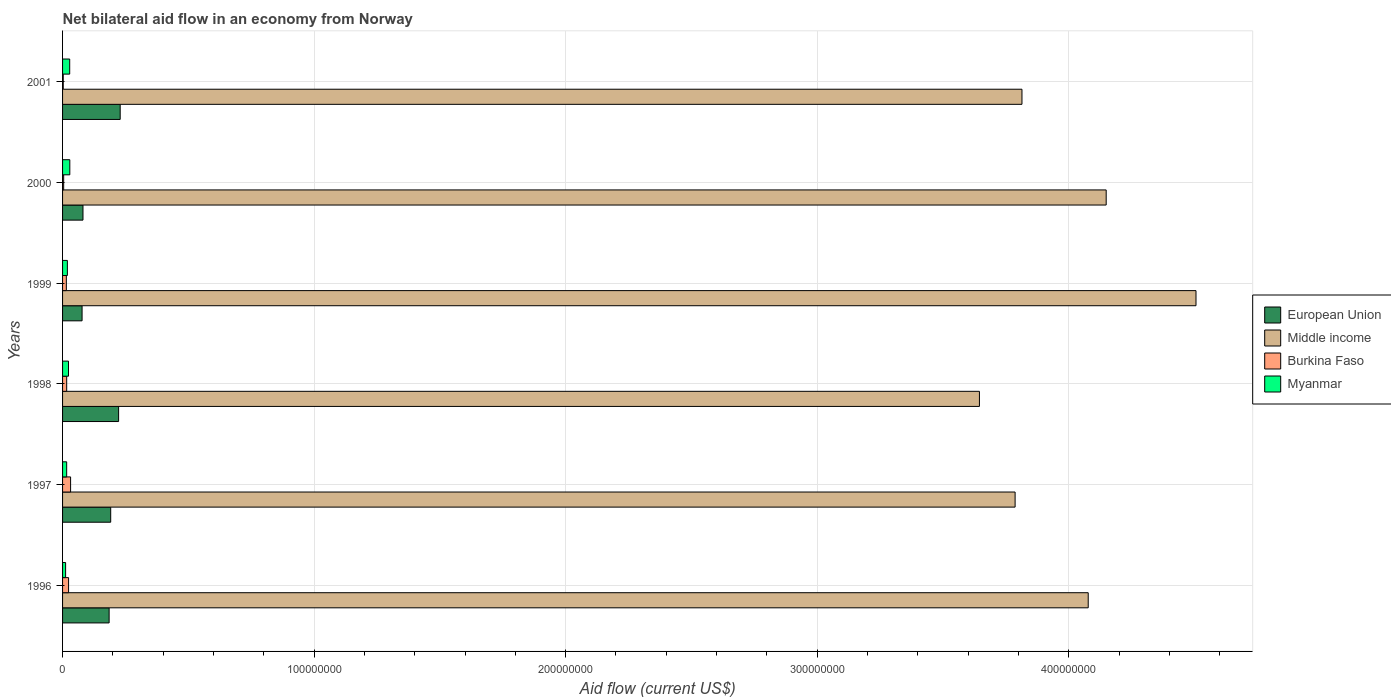How many groups of bars are there?
Offer a very short reply. 6. Are the number of bars per tick equal to the number of legend labels?
Give a very brief answer. Yes. Are the number of bars on each tick of the Y-axis equal?
Your response must be concise. Yes. How many bars are there on the 2nd tick from the top?
Give a very brief answer. 4. What is the label of the 2nd group of bars from the top?
Offer a terse response. 2000. In how many cases, is the number of bars for a given year not equal to the number of legend labels?
Your answer should be compact. 0. What is the net bilateral aid flow in Myanmar in 2001?
Offer a very short reply. 2.84e+06. Across all years, what is the maximum net bilateral aid flow in Middle income?
Keep it short and to the point. 4.51e+08. Across all years, what is the minimum net bilateral aid flow in Middle income?
Your answer should be very brief. 3.65e+08. In which year was the net bilateral aid flow in Burkina Faso maximum?
Offer a terse response. 1997. In which year was the net bilateral aid flow in European Union minimum?
Offer a very short reply. 1999. What is the total net bilateral aid flow in Middle income in the graph?
Provide a succinct answer. 2.40e+09. What is the difference between the net bilateral aid flow in Myanmar in 1999 and that in 2001?
Your response must be concise. -9.30e+05. What is the average net bilateral aid flow in Burkina Faso per year?
Keep it short and to the point. 1.57e+06. In the year 1996, what is the difference between the net bilateral aid flow in Myanmar and net bilateral aid flow in European Union?
Ensure brevity in your answer.  -1.73e+07. In how many years, is the net bilateral aid flow in Burkina Faso greater than 240000000 US$?
Keep it short and to the point. 0. What is the ratio of the net bilateral aid flow in Myanmar in 1997 to that in 1998?
Keep it short and to the point. 0.69. Is the net bilateral aid flow in Middle income in 1997 less than that in 2001?
Your answer should be very brief. Yes. Is the difference between the net bilateral aid flow in Myanmar in 1998 and 2001 greater than the difference between the net bilateral aid flow in European Union in 1998 and 2001?
Offer a very short reply. Yes. What is the difference between the highest and the second highest net bilateral aid flow in Myanmar?
Provide a short and direct response. 4.00e+04. What is the difference between the highest and the lowest net bilateral aid flow in European Union?
Your answer should be very brief. 1.52e+07. In how many years, is the net bilateral aid flow in European Union greater than the average net bilateral aid flow in European Union taken over all years?
Offer a very short reply. 4. Is the sum of the net bilateral aid flow in Myanmar in 1996 and 1997 greater than the maximum net bilateral aid flow in Burkina Faso across all years?
Your answer should be very brief. No. What does the 2nd bar from the top in 1996 represents?
Your answer should be very brief. Burkina Faso. What does the 3rd bar from the bottom in 1999 represents?
Offer a terse response. Burkina Faso. Is it the case that in every year, the sum of the net bilateral aid flow in European Union and net bilateral aid flow in Myanmar is greater than the net bilateral aid flow in Burkina Faso?
Your answer should be compact. Yes. How many years are there in the graph?
Your answer should be compact. 6. Where does the legend appear in the graph?
Give a very brief answer. Center right. How many legend labels are there?
Provide a succinct answer. 4. What is the title of the graph?
Your answer should be compact. Net bilateral aid flow in an economy from Norway. What is the label or title of the Y-axis?
Offer a very short reply. Years. What is the Aid flow (current US$) of European Union in 1996?
Your response must be concise. 1.85e+07. What is the Aid flow (current US$) of Middle income in 1996?
Offer a very short reply. 4.08e+08. What is the Aid flow (current US$) of Burkina Faso in 1996?
Offer a terse response. 2.39e+06. What is the Aid flow (current US$) of Myanmar in 1996?
Your response must be concise. 1.21e+06. What is the Aid flow (current US$) in European Union in 1997?
Keep it short and to the point. 1.91e+07. What is the Aid flow (current US$) in Middle income in 1997?
Provide a short and direct response. 3.79e+08. What is the Aid flow (current US$) of Burkina Faso in 1997?
Keep it short and to the point. 3.19e+06. What is the Aid flow (current US$) in Myanmar in 1997?
Provide a short and direct response. 1.63e+06. What is the Aid flow (current US$) of European Union in 1998?
Provide a short and direct response. 2.23e+07. What is the Aid flow (current US$) in Middle income in 1998?
Ensure brevity in your answer.  3.65e+08. What is the Aid flow (current US$) in Burkina Faso in 1998?
Keep it short and to the point. 1.64e+06. What is the Aid flow (current US$) in Myanmar in 1998?
Ensure brevity in your answer.  2.36e+06. What is the Aid flow (current US$) of European Union in 1999?
Ensure brevity in your answer.  7.76e+06. What is the Aid flow (current US$) of Middle income in 1999?
Offer a terse response. 4.51e+08. What is the Aid flow (current US$) of Burkina Faso in 1999?
Your response must be concise. 1.50e+06. What is the Aid flow (current US$) of Myanmar in 1999?
Your answer should be very brief. 1.91e+06. What is the Aid flow (current US$) in European Union in 2000?
Make the answer very short. 8.12e+06. What is the Aid flow (current US$) in Middle income in 2000?
Keep it short and to the point. 4.15e+08. What is the Aid flow (current US$) in Myanmar in 2000?
Make the answer very short. 2.88e+06. What is the Aid flow (current US$) in European Union in 2001?
Your answer should be compact. 2.29e+07. What is the Aid flow (current US$) of Middle income in 2001?
Keep it short and to the point. 3.81e+08. What is the Aid flow (current US$) of Myanmar in 2001?
Your answer should be very brief. 2.84e+06. Across all years, what is the maximum Aid flow (current US$) in European Union?
Provide a short and direct response. 2.29e+07. Across all years, what is the maximum Aid flow (current US$) in Middle income?
Offer a terse response. 4.51e+08. Across all years, what is the maximum Aid flow (current US$) in Burkina Faso?
Offer a very short reply. 3.19e+06. Across all years, what is the maximum Aid flow (current US$) in Myanmar?
Ensure brevity in your answer.  2.88e+06. Across all years, what is the minimum Aid flow (current US$) in European Union?
Offer a terse response. 7.76e+06. Across all years, what is the minimum Aid flow (current US$) of Middle income?
Your answer should be compact. 3.65e+08. Across all years, what is the minimum Aid flow (current US$) in Myanmar?
Provide a short and direct response. 1.21e+06. What is the total Aid flow (current US$) in European Union in the graph?
Your answer should be very brief. 9.87e+07. What is the total Aid flow (current US$) of Middle income in the graph?
Give a very brief answer. 2.40e+09. What is the total Aid flow (current US$) in Burkina Faso in the graph?
Your answer should be very brief. 9.43e+06. What is the total Aid flow (current US$) in Myanmar in the graph?
Ensure brevity in your answer.  1.28e+07. What is the difference between the Aid flow (current US$) of European Union in 1996 and that in 1997?
Your answer should be very brief. -6.30e+05. What is the difference between the Aid flow (current US$) in Middle income in 1996 and that in 1997?
Give a very brief answer. 2.91e+07. What is the difference between the Aid flow (current US$) of Burkina Faso in 1996 and that in 1997?
Make the answer very short. -8.00e+05. What is the difference between the Aid flow (current US$) in Myanmar in 1996 and that in 1997?
Ensure brevity in your answer.  -4.20e+05. What is the difference between the Aid flow (current US$) in European Union in 1996 and that in 1998?
Provide a short and direct response. -3.77e+06. What is the difference between the Aid flow (current US$) in Middle income in 1996 and that in 1998?
Offer a terse response. 4.32e+07. What is the difference between the Aid flow (current US$) of Burkina Faso in 1996 and that in 1998?
Keep it short and to the point. 7.50e+05. What is the difference between the Aid flow (current US$) of Myanmar in 1996 and that in 1998?
Make the answer very short. -1.15e+06. What is the difference between the Aid flow (current US$) of European Union in 1996 and that in 1999?
Ensure brevity in your answer.  1.08e+07. What is the difference between the Aid flow (current US$) in Middle income in 1996 and that in 1999?
Offer a very short reply. -4.28e+07. What is the difference between the Aid flow (current US$) of Burkina Faso in 1996 and that in 1999?
Keep it short and to the point. 8.90e+05. What is the difference between the Aid flow (current US$) of Myanmar in 1996 and that in 1999?
Offer a terse response. -7.00e+05. What is the difference between the Aid flow (current US$) of European Union in 1996 and that in 2000?
Your response must be concise. 1.04e+07. What is the difference between the Aid flow (current US$) in Middle income in 1996 and that in 2000?
Keep it short and to the point. -7.14e+06. What is the difference between the Aid flow (current US$) in Burkina Faso in 1996 and that in 2000?
Keep it short and to the point. 1.95e+06. What is the difference between the Aid flow (current US$) in Myanmar in 1996 and that in 2000?
Ensure brevity in your answer.  -1.67e+06. What is the difference between the Aid flow (current US$) in European Union in 1996 and that in 2001?
Provide a short and direct response. -4.40e+06. What is the difference between the Aid flow (current US$) of Middle income in 1996 and that in 2001?
Provide a short and direct response. 2.63e+07. What is the difference between the Aid flow (current US$) of Burkina Faso in 1996 and that in 2001?
Provide a short and direct response. 2.12e+06. What is the difference between the Aid flow (current US$) in Myanmar in 1996 and that in 2001?
Give a very brief answer. -1.63e+06. What is the difference between the Aid flow (current US$) in European Union in 1997 and that in 1998?
Ensure brevity in your answer.  -3.14e+06. What is the difference between the Aid flow (current US$) in Middle income in 1997 and that in 1998?
Provide a short and direct response. 1.42e+07. What is the difference between the Aid flow (current US$) in Burkina Faso in 1997 and that in 1998?
Keep it short and to the point. 1.55e+06. What is the difference between the Aid flow (current US$) in Myanmar in 1997 and that in 1998?
Offer a very short reply. -7.30e+05. What is the difference between the Aid flow (current US$) in European Union in 1997 and that in 1999?
Provide a succinct answer. 1.14e+07. What is the difference between the Aid flow (current US$) in Middle income in 1997 and that in 1999?
Your answer should be very brief. -7.19e+07. What is the difference between the Aid flow (current US$) in Burkina Faso in 1997 and that in 1999?
Provide a succinct answer. 1.69e+06. What is the difference between the Aid flow (current US$) in Myanmar in 1997 and that in 1999?
Keep it short and to the point. -2.80e+05. What is the difference between the Aid flow (current US$) of European Union in 1997 and that in 2000?
Ensure brevity in your answer.  1.10e+07. What is the difference between the Aid flow (current US$) in Middle income in 1997 and that in 2000?
Make the answer very short. -3.62e+07. What is the difference between the Aid flow (current US$) of Burkina Faso in 1997 and that in 2000?
Give a very brief answer. 2.75e+06. What is the difference between the Aid flow (current US$) in Myanmar in 1997 and that in 2000?
Provide a succinct answer. -1.25e+06. What is the difference between the Aid flow (current US$) in European Union in 1997 and that in 2001?
Your response must be concise. -3.77e+06. What is the difference between the Aid flow (current US$) of Middle income in 1997 and that in 2001?
Keep it short and to the point. -2.73e+06. What is the difference between the Aid flow (current US$) in Burkina Faso in 1997 and that in 2001?
Provide a short and direct response. 2.92e+06. What is the difference between the Aid flow (current US$) of Myanmar in 1997 and that in 2001?
Your response must be concise. -1.21e+06. What is the difference between the Aid flow (current US$) in European Union in 1998 and that in 1999?
Ensure brevity in your answer.  1.45e+07. What is the difference between the Aid flow (current US$) of Middle income in 1998 and that in 1999?
Make the answer very short. -8.61e+07. What is the difference between the Aid flow (current US$) of Burkina Faso in 1998 and that in 1999?
Offer a very short reply. 1.40e+05. What is the difference between the Aid flow (current US$) in European Union in 1998 and that in 2000?
Provide a short and direct response. 1.42e+07. What is the difference between the Aid flow (current US$) in Middle income in 1998 and that in 2000?
Make the answer very short. -5.04e+07. What is the difference between the Aid flow (current US$) in Burkina Faso in 1998 and that in 2000?
Provide a succinct answer. 1.20e+06. What is the difference between the Aid flow (current US$) in Myanmar in 1998 and that in 2000?
Your answer should be very brief. -5.20e+05. What is the difference between the Aid flow (current US$) in European Union in 1998 and that in 2001?
Provide a short and direct response. -6.30e+05. What is the difference between the Aid flow (current US$) of Middle income in 1998 and that in 2001?
Your response must be concise. -1.69e+07. What is the difference between the Aid flow (current US$) of Burkina Faso in 1998 and that in 2001?
Offer a terse response. 1.37e+06. What is the difference between the Aid flow (current US$) of Myanmar in 1998 and that in 2001?
Keep it short and to the point. -4.80e+05. What is the difference between the Aid flow (current US$) in European Union in 1999 and that in 2000?
Ensure brevity in your answer.  -3.60e+05. What is the difference between the Aid flow (current US$) of Middle income in 1999 and that in 2000?
Ensure brevity in your answer.  3.57e+07. What is the difference between the Aid flow (current US$) of Burkina Faso in 1999 and that in 2000?
Provide a short and direct response. 1.06e+06. What is the difference between the Aid flow (current US$) in Myanmar in 1999 and that in 2000?
Ensure brevity in your answer.  -9.70e+05. What is the difference between the Aid flow (current US$) of European Union in 1999 and that in 2001?
Offer a very short reply. -1.52e+07. What is the difference between the Aid flow (current US$) of Middle income in 1999 and that in 2001?
Your response must be concise. 6.92e+07. What is the difference between the Aid flow (current US$) of Burkina Faso in 1999 and that in 2001?
Your answer should be compact. 1.23e+06. What is the difference between the Aid flow (current US$) of Myanmar in 1999 and that in 2001?
Offer a very short reply. -9.30e+05. What is the difference between the Aid flow (current US$) in European Union in 2000 and that in 2001?
Provide a succinct answer. -1.48e+07. What is the difference between the Aid flow (current US$) in Middle income in 2000 and that in 2001?
Offer a terse response. 3.35e+07. What is the difference between the Aid flow (current US$) in Myanmar in 2000 and that in 2001?
Provide a short and direct response. 4.00e+04. What is the difference between the Aid flow (current US$) of European Union in 1996 and the Aid flow (current US$) of Middle income in 1997?
Ensure brevity in your answer.  -3.60e+08. What is the difference between the Aid flow (current US$) in European Union in 1996 and the Aid flow (current US$) in Burkina Faso in 1997?
Your answer should be very brief. 1.53e+07. What is the difference between the Aid flow (current US$) in European Union in 1996 and the Aid flow (current US$) in Myanmar in 1997?
Your answer should be compact. 1.69e+07. What is the difference between the Aid flow (current US$) in Middle income in 1996 and the Aid flow (current US$) in Burkina Faso in 1997?
Keep it short and to the point. 4.05e+08. What is the difference between the Aid flow (current US$) of Middle income in 1996 and the Aid flow (current US$) of Myanmar in 1997?
Offer a terse response. 4.06e+08. What is the difference between the Aid flow (current US$) of Burkina Faso in 1996 and the Aid flow (current US$) of Myanmar in 1997?
Offer a terse response. 7.60e+05. What is the difference between the Aid flow (current US$) in European Union in 1996 and the Aid flow (current US$) in Middle income in 1998?
Your answer should be compact. -3.46e+08. What is the difference between the Aid flow (current US$) in European Union in 1996 and the Aid flow (current US$) in Burkina Faso in 1998?
Your answer should be very brief. 1.69e+07. What is the difference between the Aid flow (current US$) in European Union in 1996 and the Aid flow (current US$) in Myanmar in 1998?
Provide a succinct answer. 1.62e+07. What is the difference between the Aid flow (current US$) in Middle income in 1996 and the Aid flow (current US$) in Burkina Faso in 1998?
Your answer should be very brief. 4.06e+08. What is the difference between the Aid flow (current US$) in Middle income in 1996 and the Aid flow (current US$) in Myanmar in 1998?
Provide a short and direct response. 4.05e+08. What is the difference between the Aid flow (current US$) in Burkina Faso in 1996 and the Aid flow (current US$) in Myanmar in 1998?
Provide a short and direct response. 3.00e+04. What is the difference between the Aid flow (current US$) of European Union in 1996 and the Aid flow (current US$) of Middle income in 1999?
Offer a very short reply. -4.32e+08. What is the difference between the Aid flow (current US$) of European Union in 1996 and the Aid flow (current US$) of Burkina Faso in 1999?
Your answer should be very brief. 1.70e+07. What is the difference between the Aid flow (current US$) in European Union in 1996 and the Aid flow (current US$) in Myanmar in 1999?
Ensure brevity in your answer.  1.66e+07. What is the difference between the Aid flow (current US$) in Middle income in 1996 and the Aid flow (current US$) in Burkina Faso in 1999?
Your response must be concise. 4.06e+08. What is the difference between the Aid flow (current US$) of Middle income in 1996 and the Aid flow (current US$) of Myanmar in 1999?
Provide a succinct answer. 4.06e+08. What is the difference between the Aid flow (current US$) of European Union in 1996 and the Aid flow (current US$) of Middle income in 2000?
Give a very brief answer. -3.96e+08. What is the difference between the Aid flow (current US$) in European Union in 1996 and the Aid flow (current US$) in Burkina Faso in 2000?
Offer a terse response. 1.81e+07. What is the difference between the Aid flow (current US$) of European Union in 1996 and the Aid flow (current US$) of Myanmar in 2000?
Provide a short and direct response. 1.56e+07. What is the difference between the Aid flow (current US$) in Middle income in 1996 and the Aid flow (current US$) in Burkina Faso in 2000?
Make the answer very short. 4.07e+08. What is the difference between the Aid flow (current US$) of Middle income in 1996 and the Aid flow (current US$) of Myanmar in 2000?
Give a very brief answer. 4.05e+08. What is the difference between the Aid flow (current US$) in Burkina Faso in 1996 and the Aid flow (current US$) in Myanmar in 2000?
Give a very brief answer. -4.90e+05. What is the difference between the Aid flow (current US$) of European Union in 1996 and the Aid flow (current US$) of Middle income in 2001?
Offer a terse response. -3.63e+08. What is the difference between the Aid flow (current US$) of European Union in 1996 and the Aid flow (current US$) of Burkina Faso in 2001?
Offer a terse response. 1.82e+07. What is the difference between the Aid flow (current US$) of European Union in 1996 and the Aid flow (current US$) of Myanmar in 2001?
Ensure brevity in your answer.  1.57e+07. What is the difference between the Aid flow (current US$) in Middle income in 1996 and the Aid flow (current US$) in Burkina Faso in 2001?
Your response must be concise. 4.07e+08. What is the difference between the Aid flow (current US$) in Middle income in 1996 and the Aid flow (current US$) in Myanmar in 2001?
Ensure brevity in your answer.  4.05e+08. What is the difference between the Aid flow (current US$) in Burkina Faso in 1996 and the Aid flow (current US$) in Myanmar in 2001?
Provide a short and direct response. -4.50e+05. What is the difference between the Aid flow (current US$) in European Union in 1997 and the Aid flow (current US$) in Middle income in 1998?
Your answer should be compact. -3.45e+08. What is the difference between the Aid flow (current US$) in European Union in 1997 and the Aid flow (current US$) in Burkina Faso in 1998?
Offer a very short reply. 1.75e+07. What is the difference between the Aid flow (current US$) of European Union in 1997 and the Aid flow (current US$) of Myanmar in 1998?
Give a very brief answer. 1.68e+07. What is the difference between the Aid flow (current US$) of Middle income in 1997 and the Aid flow (current US$) of Burkina Faso in 1998?
Keep it short and to the point. 3.77e+08. What is the difference between the Aid flow (current US$) in Middle income in 1997 and the Aid flow (current US$) in Myanmar in 1998?
Your answer should be very brief. 3.76e+08. What is the difference between the Aid flow (current US$) in Burkina Faso in 1997 and the Aid flow (current US$) in Myanmar in 1998?
Ensure brevity in your answer.  8.30e+05. What is the difference between the Aid flow (current US$) in European Union in 1997 and the Aid flow (current US$) in Middle income in 1999?
Provide a succinct answer. -4.31e+08. What is the difference between the Aid flow (current US$) in European Union in 1997 and the Aid flow (current US$) in Burkina Faso in 1999?
Provide a succinct answer. 1.76e+07. What is the difference between the Aid flow (current US$) in European Union in 1997 and the Aid flow (current US$) in Myanmar in 1999?
Provide a succinct answer. 1.72e+07. What is the difference between the Aid flow (current US$) in Middle income in 1997 and the Aid flow (current US$) in Burkina Faso in 1999?
Offer a terse response. 3.77e+08. What is the difference between the Aid flow (current US$) of Middle income in 1997 and the Aid flow (current US$) of Myanmar in 1999?
Your answer should be compact. 3.77e+08. What is the difference between the Aid flow (current US$) of Burkina Faso in 1997 and the Aid flow (current US$) of Myanmar in 1999?
Give a very brief answer. 1.28e+06. What is the difference between the Aid flow (current US$) in European Union in 1997 and the Aid flow (current US$) in Middle income in 2000?
Make the answer very short. -3.96e+08. What is the difference between the Aid flow (current US$) in European Union in 1997 and the Aid flow (current US$) in Burkina Faso in 2000?
Your answer should be compact. 1.87e+07. What is the difference between the Aid flow (current US$) in European Union in 1997 and the Aid flow (current US$) in Myanmar in 2000?
Offer a very short reply. 1.63e+07. What is the difference between the Aid flow (current US$) of Middle income in 1997 and the Aid flow (current US$) of Burkina Faso in 2000?
Your answer should be very brief. 3.78e+08. What is the difference between the Aid flow (current US$) in Middle income in 1997 and the Aid flow (current US$) in Myanmar in 2000?
Make the answer very short. 3.76e+08. What is the difference between the Aid flow (current US$) in Burkina Faso in 1997 and the Aid flow (current US$) in Myanmar in 2000?
Your answer should be very brief. 3.10e+05. What is the difference between the Aid flow (current US$) of European Union in 1997 and the Aid flow (current US$) of Middle income in 2001?
Offer a very short reply. -3.62e+08. What is the difference between the Aid flow (current US$) in European Union in 1997 and the Aid flow (current US$) in Burkina Faso in 2001?
Ensure brevity in your answer.  1.89e+07. What is the difference between the Aid flow (current US$) in European Union in 1997 and the Aid flow (current US$) in Myanmar in 2001?
Keep it short and to the point. 1.63e+07. What is the difference between the Aid flow (current US$) of Middle income in 1997 and the Aid flow (current US$) of Burkina Faso in 2001?
Provide a succinct answer. 3.78e+08. What is the difference between the Aid flow (current US$) in Middle income in 1997 and the Aid flow (current US$) in Myanmar in 2001?
Provide a short and direct response. 3.76e+08. What is the difference between the Aid flow (current US$) of Burkina Faso in 1997 and the Aid flow (current US$) of Myanmar in 2001?
Offer a terse response. 3.50e+05. What is the difference between the Aid flow (current US$) in European Union in 1998 and the Aid flow (current US$) in Middle income in 1999?
Provide a short and direct response. -4.28e+08. What is the difference between the Aid flow (current US$) of European Union in 1998 and the Aid flow (current US$) of Burkina Faso in 1999?
Provide a short and direct response. 2.08e+07. What is the difference between the Aid flow (current US$) of European Union in 1998 and the Aid flow (current US$) of Myanmar in 1999?
Offer a very short reply. 2.04e+07. What is the difference between the Aid flow (current US$) in Middle income in 1998 and the Aid flow (current US$) in Burkina Faso in 1999?
Keep it short and to the point. 3.63e+08. What is the difference between the Aid flow (current US$) of Middle income in 1998 and the Aid flow (current US$) of Myanmar in 1999?
Your answer should be compact. 3.63e+08. What is the difference between the Aid flow (current US$) in European Union in 1998 and the Aid flow (current US$) in Middle income in 2000?
Provide a short and direct response. -3.93e+08. What is the difference between the Aid flow (current US$) in European Union in 1998 and the Aid flow (current US$) in Burkina Faso in 2000?
Your answer should be very brief. 2.18e+07. What is the difference between the Aid flow (current US$) in European Union in 1998 and the Aid flow (current US$) in Myanmar in 2000?
Ensure brevity in your answer.  1.94e+07. What is the difference between the Aid flow (current US$) of Middle income in 1998 and the Aid flow (current US$) of Burkina Faso in 2000?
Your answer should be compact. 3.64e+08. What is the difference between the Aid flow (current US$) of Middle income in 1998 and the Aid flow (current US$) of Myanmar in 2000?
Your response must be concise. 3.62e+08. What is the difference between the Aid flow (current US$) in Burkina Faso in 1998 and the Aid flow (current US$) in Myanmar in 2000?
Make the answer very short. -1.24e+06. What is the difference between the Aid flow (current US$) in European Union in 1998 and the Aid flow (current US$) in Middle income in 2001?
Provide a short and direct response. -3.59e+08. What is the difference between the Aid flow (current US$) in European Union in 1998 and the Aid flow (current US$) in Burkina Faso in 2001?
Provide a short and direct response. 2.20e+07. What is the difference between the Aid flow (current US$) in European Union in 1998 and the Aid flow (current US$) in Myanmar in 2001?
Provide a short and direct response. 1.94e+07. What is the difference between the Aid flow (current US$) in Middle income in 1998 and the Aid flow (current US$) in Burkina Faso in 2001?
Your answer should be compact. 3.64e+08. What is the difference between the Aid flow (current US$) in Middle income in 1998 and the Aid flow (current US$) in Myanmar in 2001?
Your response must be concise. 3.62e+08. What is the difference between the Aid flow (current US$) in Burkina Faso in 1998 and the Aid flow (current US$) in Myanmar in 2001?
Your response must be concise. -1.20e+06. What is the difference between the Aid flow (current US$) in European Union in 1999 and the Aid flow (current US$) in Middle income in 2000?
Make the answer very short. -4.07e+08. What is the difference between the Aid flow (current US$) of European Union in 1999 and the Aid flow (current US$) of Burkina Faso in 2000?
Your answer should be compact. 7.32e+06. What is the difference between the Aid flow (current US$) of European Union in 1999 and the Aid flow (current US$) of Myanmar in 2000?
Offer a terse response. 4.88e+06. What is the difference between the Aid flow (current US$) in Middle income in 1999 and the Aid flow (current US$) in Burkina Faso in 2000?
Give a very brief answer. 4.50e+08. What is the difference between the Aid flow (current US$) in Middle income in 1999 and the Aid flow (current US$) in Myanmar in 2000?
Your answer should be very brief. 4.48e+08. What is the difference between the Aid flow (current US$) of Burkina Faso in 1999 and the Aid flow (current US$) of Myanmar in 2000?
Your answer should be compact. -1.38e+06. What is the difference between the Aid flow (current US$) in European Union in 1999 and the Aid flow (current US$) in Middle income in 2001?
Provide a short and direct response. -3.74e+08. What is the difference between the Aid flow (current US$) in European Union in 1999 and the Aid flow (current US$) in Burkina Faso in 2001?
Your response must be concise. 7.49e+06. What is the difference between the Aid flow (current US$) of European Union in 1999 and the Aid flow (current US$) of Myanmar in 2001?
Give a very brief answer. 4.92e+06. What is the difference between the Aid flow (current US$) of Middle income in 1999 and the Aid flow (current US$) of Burkina Faso in 2001?
Offer a terse response. 4.50e+08. What is the difference between the Aid flow (current US$) in Middle income in 1999 and the Aid flow (current US$) in Myanmar in 2001?
Ensure brevity in your answer.  4.48e+08. What is the difference between the Aid flow (current US$) in Burkina Faso in 1999 and the Aid flow (current US$) in Myanmar in 2001?
Ensure brevity in your answer.  -1.34e+06. What is the difference between the Aid flow (current US$) of European Union in 2000 and the Aid flow (current US$) of Middle income in 2001?
Provide a short and direct response. -3.73e+08. What is the difference between the Aid flow (current US$) of European Union in 2000 and the Aid flow (current US$) of Burkina Faso in 2001?
Provide a short and direct response. 7.85e+06. What is the difference between the Aid flow (current US$) of European Union in 2000 and the Aid flow (current US$) of Myanmar in 2001?
Provide a succinct answer. 5.28e+06. What is the difference between the Aid flow (current US$) of Middle income in 2000 and the Aid flow (current US$) of Burkina Faso in 2001?
Ensure brevity in your answer.  4.15e+08. What is the difference between the Aid flow (current US$) in Middle income in 2000 and the Aid flow (current US$) in Myanmar in 2001?
Your response must be concise. 4.12e+08. What is the difference between the Aid flow (current US$) in Burkina Faso in 2000 and the Aid flow (current US$) in Myanmar in 2001?
Your answer should be very brief. -2.40e+06. What is the average Aid flow (current US$) in European Union per year?
Provide a succinct answer. 1.65e+07. What is the average Aid flow (current US$) in Middle income per year?
Offer a very short reply. 4.00e+08. What is the average Aid flow (current US$) in Burkina Faso per year?
Make the answer very short. 1.57e+06. What is the average Aid flow (current US$) of Myanmar per year?
Make the answer very short. 2.14e+06. In the year 1996, what is the difference between the Aid flow (current US$) of European Union and Aid flow (current US$) of Middle income?
Keep it short and to the point. -3.89e+08. In the year 1996, what is the difference between the Aid flow (current US$) in European Union and Aid flow (current US$) in Burkina Faso?
Make the answer very short. 1.61e+07. In the year 1996, what is the difference between the Aid flow (current US$) in European Union and Aid flow (current US$) in Myanmar?
Provide a short and direct response. 1.73e+07. In the year 1996, what is the difference between the Aid flow (current US$) of Middle income and Aid flow (current US$) of Burkina Faso?
Make the answer very short. 4.05e+08. In the year 1996, what is the difference between the Aid flow (current US$) of Middle income and Aid flow (current US$) of Myanmar?
Your response must be concise. 4.07e+08. In the year 1996, what is the difference between the Aid flow (current US$) in Burkina Faso and Aid flow (current US$) in Myanmar?
Provide a short and direct response. 1.18e+06. In the year 1997, what is the difference between the Aid flow (current US$) of European Union and Aid flow (current US$) of Middle income?
Make the answer very short. -3.60e+08. In the year 1997, what is the difference between the Aid flow (current US$) in European Union and Aid flow (current US$) in Burkina Faso?
Offer a very short reply. 1.60e+07. In the year 1997, what is the difference between the Aid flow (current US$) in European Union and Aid flow (current US$) in Myanmar?
Offer a very short reply. 1.75e+07. In the year 1997, what is the difference between the Aid flow (current US$) of Middle income and Aid flow (current US$) of Burkina Faso?
Keep it short and to the point. 3.76e+08. In the year 1997, what is the difference between the Aid flow (current US$) of Middle income and Aid flow (current US$) of Myanmar?
Make the answer very short. 3.77e+08. In the year 1997, what is the difference between the Aid flow (current US$) in Burkina Faso and Aid flow (current US$) in Myanmar?
Provide a succinct answer. 1.56e+06. In the year 1998, what is the difference between the Aid flow (current US$) of European Union and Aid flow (current US$) of Middle income?
Offer a terse response. -3.42e+08. In the year 1998, what is the difference between the Aid flow (current US$) in European Union and Aid flow (current US$) in Burkina Faso?
Ensure brevity in your answer.  2.06e+07. In the year 1998, what is the difference between the Aid flow (current US$) in European Union and Aid flow (current US$) in Myanmar?
Keep it short and to the point. 1.99e+07. In the year 1998, what is the difference between the Aid flow (current US$) in Middle income and Aid flow (current US$) in Burkina Faso?
Keep it short and to the point. 3.63e+08. In the year 1998, what is the difference between the Aid flow (current US$) of Middle income and Aid flow (current US$) of Myanmar?
Keep it short and to the point. 3.62e+08. In the year 1998, what is the difference between the Aid flow (current US$) in Burkina Faso and Aid flow (current US$) in Myanmar?
Provide a succinct answer. -7.20e+05. In the year 1999, what is the difference between the Aid flow (current US$) of European Union and Aid flow (current US$) of Middle income?
Make the answer very short. -4.43e+08. In the year 1999, what is the difference between the Aid flow (current US$) in European Union and Aid flow (current US$) in Burkina Faso?
Make the answer very short. 6.26e+06. In the year 1999, what is the difference between the Aid flow (current US$) in European Union and Aid flow (current US$) in Myanmar?
Offer a very short reply. 5.85e+06. In the year 1999, what is the difference between the Aid flow (current US$) of Middle income and Aid flow (current US$) of Burkina Faso?
Give a very brief answer. 4.49e+08. In the year 1999, what is the difference between the Aid flow (current US$) of Middle income and Aid flow (current US$) of Myanmar?
Provide a short and direct response. 4.49e+08. In the year 1999, what is the difference between the Aid flow (current US$) in Burkina Faso and Aid flow (current US$) in Myanmar?
Offer a very short reply. -4.10e+05. In the year 2000, what is the difference between the Aid flow (current US$) in European Union and Aid flow (current US$) in Middle income?
Ensure brevity in your answer.  -4.07e+08. In the year 2000, what is the difference between the Aid flow (current US$) of European Union and Aid flow (current US$) of Burkina Faso?
Keep it short and to the point. 7.68e+06. In the year 2000, what is the difference between the Aid flow (current US$) of European Union and Aid flow (current US$) of Myanmar?
Offer a very short reply. 5.24e+06. In the year 2000, what is the difference between the Aid flow (current US$) of Middle income and Aid flow (current US$) of Burkina Faso?
Offer a very short reply. 4.14e+08. In the year 2000, what is the difference between the Aid flow (current US$) in Middle income and Aid flow (current US$) in Myanmar?
Your answer should be compact. 4.12e+08. In the year 2000, what is the difference between the Aid flow (current US$) of Burkina Faso and Aid flow (current US$) of Myanmar?
Provide a succinct answer. -2.44e+06. In the year 2001, what is the difference between the Aid flow (current US$) in European Union and Aid flow (current US$) in Middle income?
Keep it short and to the point. -3.59e+08. In the year 2001, what is the difference between the Aid flow (current US$) in European Union and Aid flow (current US$) in Burkina Faso?
Your answer should be very brief. 2.26e+07. In the year 2001, what is the difference between the Aid flow (current US$) in European Union and Aid flow (current US$) in Myanmar?
Offer a very short reply. 2.01e+07. In the year 2001, what is the difference between the Aid flow (current US$) in Middle income and Aid flow (current US$) in Burkina Faso?
Make the answer very short. 3.81e+08. In the year 2001, what is the difference between the Aid flow (current US$) of Middle income and Aid flow (current US$) of Myanmar?
Offer a very short reply. 3.79e+08. In the year 2001, what is the difference between the Aid flow (current US$) in Burkina Faso and Aid flow (current US$) in Myanmar?
Provide a succinct answer. -2.57e+06. What is the ratio of the Aid flow (current US$) in European Union in 1996 to that in 1997?
Keep it short and to the point. 0.97. What is the ratio of the Aid flow (current US$) in Middle income in 1996 to that in 1997?
Make the answer very short. 1.08. What is the ratio of the Aid flow (current US$) in Burkina Faso in 1996 to that in 1997?
Provide a short and direct response. 0.75. What is the ratio of the Aid flow (current US$) of Myanmar in 1996 to that in 1997?
Offer a very short reply. 0.74. What is the ratio of the Aid flow (current US$) in European Union in 1996 to that in 1998?
Ensure brevity in your answer.  0.83. What is the ratio of the Aid flow (current US$) in Middle income in 1996 to that in 1998?
Your answer should be very brief. 1.12. What is the ratio of the Aid flow (current US$) in Burkina Faso in 1996 to that in 1998?
Ensure brevity in your answer.  1.46. What is the ratio of the Aid flow (current US$) in Myanmar in 1996 to that in 1998?
Offer a terse response. 0.51. What is the ratio of the Aid flow (current US$) in European Union in 1996 to that in 1999?
Your response must be concise. 2.39. What is the ratio of the Aid flow (current US$) of Middle income in 1996 to that in 1999?
Offer a terse response. 0.9. What is the ratio of the Aid flow (current US$) of Burkina Faso in 1996 to that in 1999?
Provide a succinct answer. 1.59. What is the ratio of the Aid flow (current US$) of Myanmar in 1996 to that in 1999?
Offer a terse response. 0.63. What is the ratio of the Aid flow (current US$) in European Union in 1996 to that in 2000?
Offer a very short reply. 2.28. What is the ratio of the Aid flow (current US$) of Middle income in 1996 to that in 2000?
Make the answer very short. 0.98. What is the ratio of the Aid flow (current US$) of Burkina Faso in 1996 to that in 2000?
Offer a very short reply. 5.43. What is the ratio of the Aid flow (current US$) in Myanmar in 1996 to that in 2000?
Ensure brevity in your answer.  0.42. What is the ratio of the Aid flow (current US$) of European Union in 1996 to that in 2001?
Your answer should be very brief. 0.81. What is the ratio of the Aid flow (current US$) in Middle income in 1996 to that in 2001?
Your answer should be very brief. 1.07. What is the ratio of the Aid flow (current US$) in Burkina Faso in 1996 to that in 2001?
Offer a terse response. 8.85. What is the ratio of the Aid flow (current US$) of Myanmar in 1996 to that in 2001?
Your response must be concise. 0.43. What is the ratio of the Aid flow (current US$) in European Union in 1997 to that in 1998?
Provide a short and direct response. 0.86. What is the ratio of the Aid flow (current US$) of Middle income in 1997 to that in 1998?
Offer a terse response. 1.04. What is the ratio of the Aid flow (current US$) in Burkina Faso in 1997 to that in 1998?
Make the answer very short. 1.95. What is the ratio of the Aid flow (current US$) of Myanmar in 1997 to that in 1998?
Give a very brief answer. 0.69. What is the ratio of the Aid flow (current US$) of European Union in 1997 to that in 1999?
Provide a succinct answer. 2.47. What is the ratio of the Aid flow (current US$) of Middle income in 1997 to that in 1999?
Your answer should be very brief. 0.84. What is the ratio of the Aid flow (current US$) in Burkina Faso in 1997 to that in 1999?
Your answer should be very brief. 2.13. What is the ratio of the Aid flow (current US$) of Myanmar in 1997 to that in 1999?
Give a very brief answer. 0.85. What is the ratio of the Aid flow (current US$) of European Union in 1997 to that in 2000?
Your answer should be compact. 2.36. What is the ratio of the Aid flow (current US$) of Middle income in 1997 to that in 2000?
Keep it short and to the point. 0.91. What is the ratio of the Aid flow (current US$) in Burkina Faso in 1997 to that in 2000?
Ensure brevity in your answer.  7.25. What is the ratio of the Aid flow (current US$) in Myanmar in 1997 to that in 2000?
Provide a succinct answer. 0.57. What is the ratio of the Aid flow (current US$) of European Union in 1997 to that in 2001?
Your answer should be compact. 0.84. What is the ratio of the Aid flow (current US$) of Burkina Faso in 1997 to that in 2001?
Provide a short and direct response. 11.81. What is the ratio of the Aid flow (current US$) in Myanmar in 1997 to that in 2001?
Give a very brief answer. 0.57. What is the ratio of the Aid flow (current US$) in European Union in 1998 to that in 1999?
Make the answer very short. 2.87. What is the ratio of the Aid flow (current US$) of Middle income in 1998 to that in 1999?
Keep it short and to the point. 0.81. What is the ratio of the Aid flow (current US$) in Burkina Faso in 1998 to that in 1999?
Offer a terse response. 1.09. What is the ratio of the Aid flow (current US$) of Myanmar in 1998 to that in 1999?
Offer a very short reply. 1.24. What is the ratio of the Aid flow (current US$) of European Union in 1998 to that in 2000?
Provide a succinct answer. 2.74. What is the ratio of the Aid flow (current US$) of Middle income in 1998 to that in 2000?
Provide a succinct answer. 0.88. What is the ratio of the Aid flow (current US$) of Burkina Faso in 1998 to that in 2000?
Your response must be concise. 3.73. What is the ratio of the Aid flow (current US$) of Myanmar in 1998 to that in 2000?
Your answer should be very brief. 0.82. What is the ratio of the Aid flow (current US$) in European Union in 1998 to that in 2001?
Make the answer very short. 0.97. What is the ratio of the Aid flow (current US$) in Middle income in 1998 to that in 2001?
Give a very brief answer. 0.96. What is the ratio of the Aid flow (current US$) in Burkina Faso in 1998 to that in 2001?
Your response must be concise. 6.07. What is the ratio of the Aid flow (current US$) of Myanmar in 1998 to that in 2001?
Ensure brevity in your answer.  0.83. What is the ratio of the Aid flow (current US$) in European Union in 1999 to that in 2000?
Provide a succinct answer. 0.96. What is the ratio of the Aid flow (current US$) in Middle income in 1999 to that in 2000?
Provide a succinct answer. 1.09. What is the ratio of the Aid flow (current US$) of Burkina Faso in 1999 to that in 2000?
Your answer should be compact. 3.41. What is the ratio of the Aid flow (current US$) of Myanmar in 1999 to that in 2000?
Your answer should be compact. 0.66. What is the ratio of the Aid flow (current US$) in European Union in 1999 to that in 2001?
Your answer should be very brief. 0.34. What is the ratio of the Aid flow (current US$) of Middle income in 1999 to that in 2001?
Your response must be concise. 1.18. What is the ratio of the Aid flow (current US$) of Burkina Faso in 1999 to that in 2001?
Provide a short and direct response. 5.56. What is the ratio of the Aid flow (current US$) of Myanmar in 1999 to that in 2001?
Provide a succinct answer. 0.67. What is the ratio of the Aid flow (current US$) in European Union in 2000 to that in 2001?
Make the answer very short. 0.35. What is the ratio of the Aid flow (current US$) of Middle income in 2000 to that in 2001?
Keep it short and to the point. 1.09. What is the ratio of the Aid flow (current US$) in Burkina Faso in 2000 to that in 2001?
Your response must be concise. 1.63. What is the ratio of the Aid flow (current US$) in Myanmar in 2000 to that in 2001?
Provide a short and direct response. 1.01. What is the difference between the highest and the second highest Aid flow (current US$) in European Union?
Ensure brevity in your answer.  6.30e+05. What is the difference between the highest and the second highest Aid flow (current US$) of Middle income?
Your response must be concise. 3.57e+07. What is the difference between the highest and the second highest Aid flow (current US$) in Myanmar?
Keep it short and to the point. 4.00e+04. What is the difference between the highest and the lowest Aid flow (current US$) in European Union?
Give a very brief answer. 1.52e+07. What is the difference between the highest and the lowest Aid flow (current US$) in Middle income?
Offer a very short reply. 8.61e+07. What is the difference between the highest and the lowest Aid flow (current US$) in Burkina Faso?
Your answer should be very brief. 2.92e+06. What is the difference between the highest and the lowest Aid flow (current US$) of Myanmar?
Your answer should be very brief. 1.67e+06. 